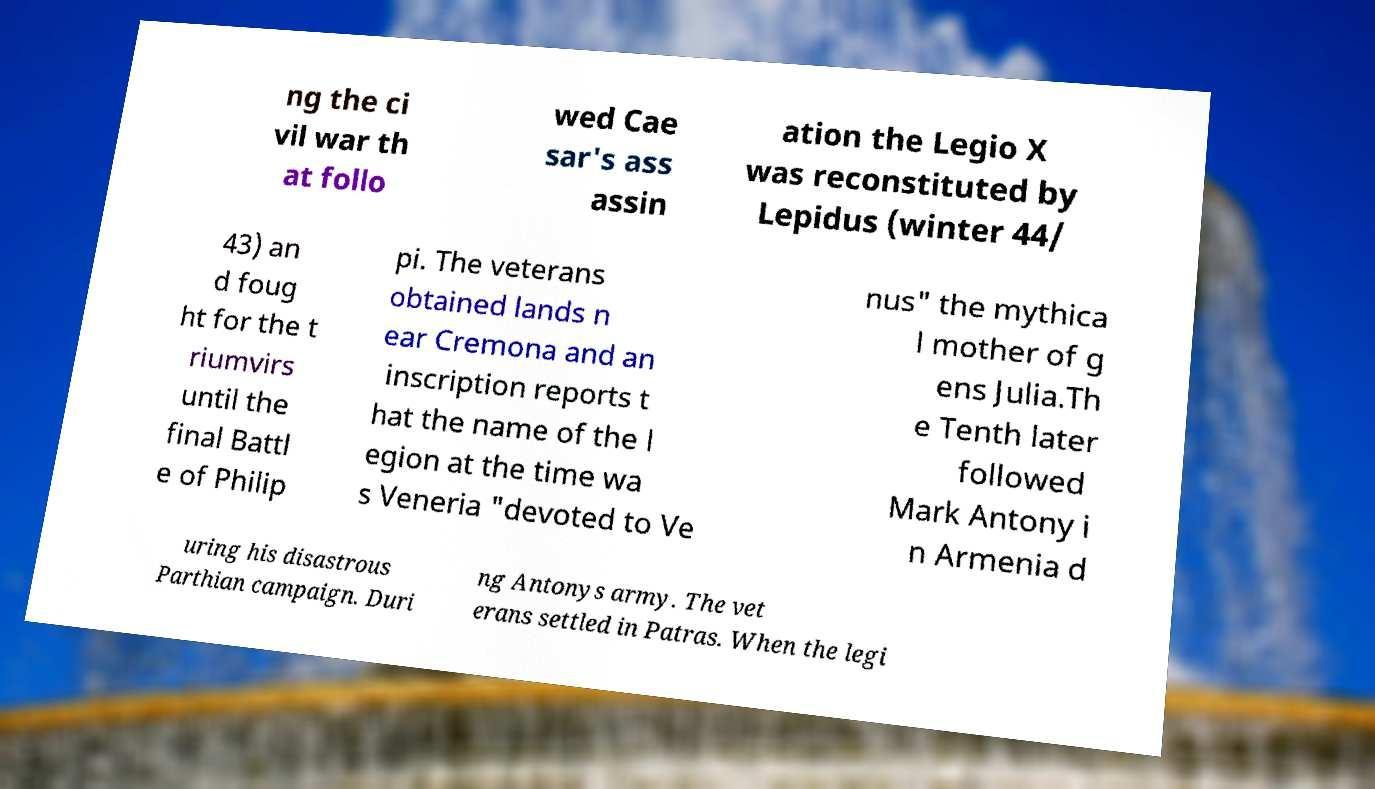Can you accurately transcribe the text from the provided image for me? ng the ci vil war th at follo wed Cae sar's ass assin ation the Legio X was reconstituted by Lepidus (winter 44/ 43) an d foug ht for the t riumvirs until the final Battl e of Philip pi. The veterans obtained lands n ear Cremona and an inscription reports t hat the name of the l egion at the time wa s Veneria "devoted to Ve nus" the mythica l mother of g ens Julia.Th e Tenth later followed Mark Antony i n Armenia d uring his disastrous Parthian campaign. Duri ng Antonys army. The vet erans settled in Patras. When the legi 